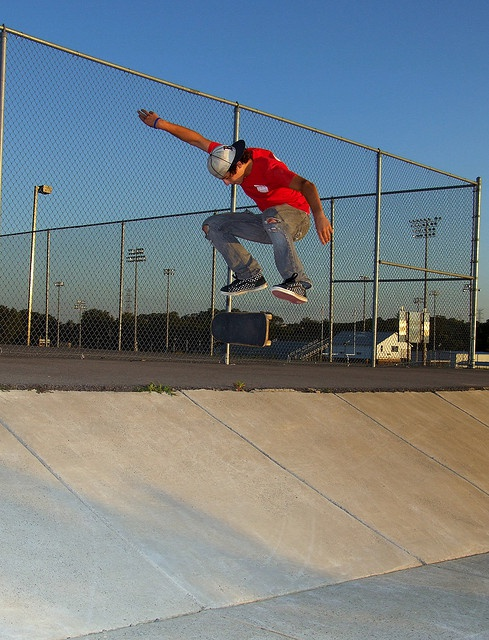Describe the objects in this image and their specific colors. I can see people in gray, black, and maroon tones and skateboard in gray, black, and maroon tones in this image. 